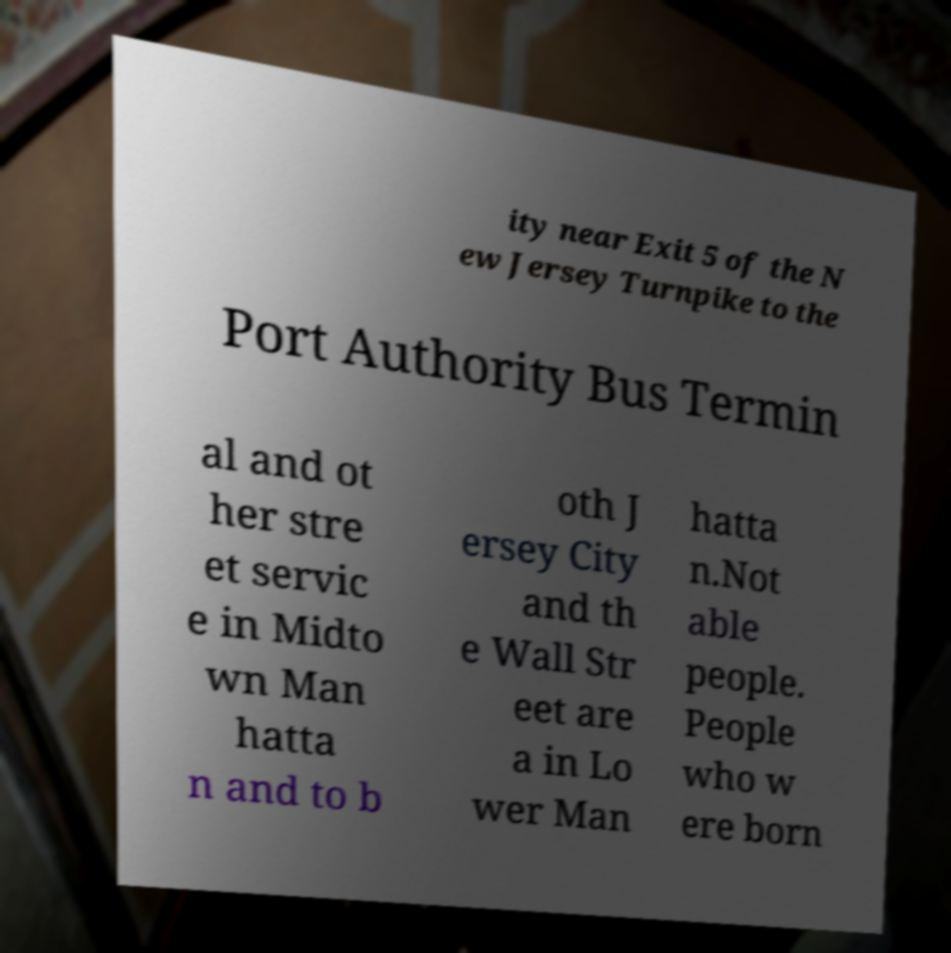Please identify and transcribe the text found in this image. ity near Exit 5 of the N ew Jersey Turnpike to the Port Authority Bus Termin al and ot her stre et servic e in Midto wn Man hatta n and to b oth J ersey City and th e Wall Str eet are a in Lo wer Man hatta n.Not able people. People who w ere born 